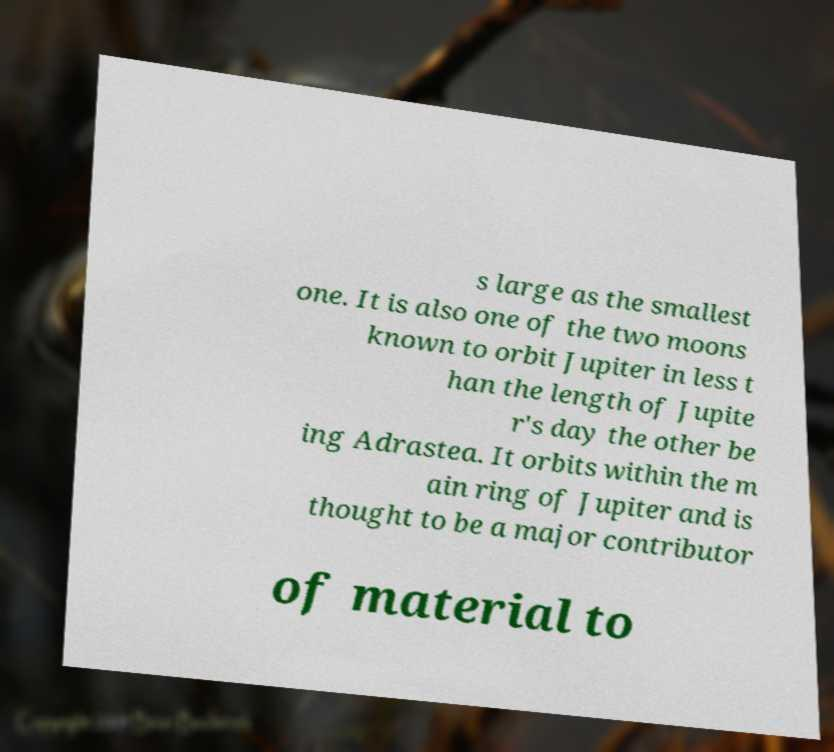I need the written content from this picture converted into text. Can you do that? s large as the smallest one. It is also one of the two moons known to orbit Jupiter in less t han the length of Jupite r's day the other be ing Adrastea. It orbits within the m ain ring of Jupiter and is thought to be a major contributor of material to 